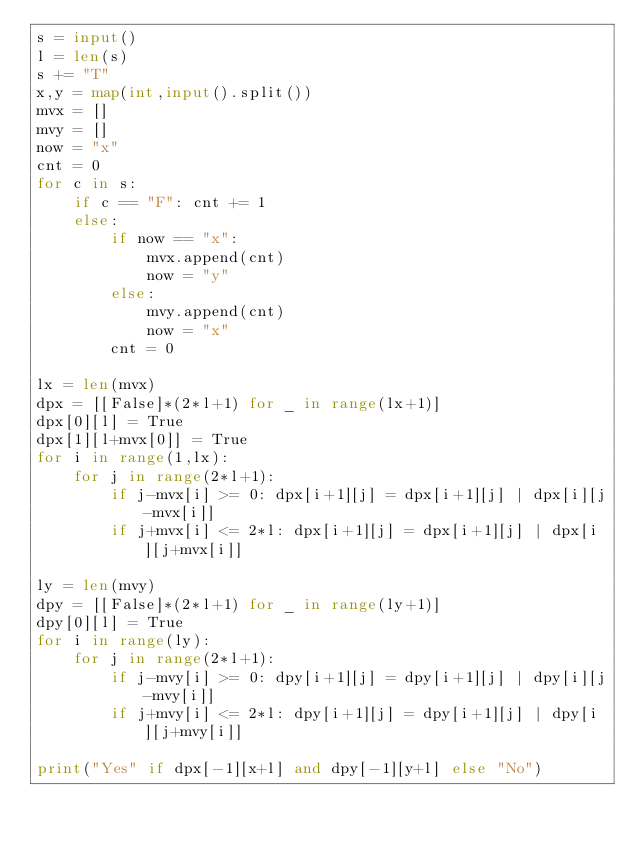Convert code to text. <code><loc_0><loc_0><loc_500><loc_500><_Python_>s = input()
l = len(s)
s += "T"
x,y = map(int,input().split())
mvx = []
mvy = []
now = "x"
cnt = 0
for c in s:
    if c == "F": cnt += 1
    else:
        if now == "x":
            mvx.append(cnt)
            now = "y"
        else:
            mvy.append(cnt)
            now = "x"
        cnt = 0

lx = len(mvx)
dpx = [[False]*(2*l+1) for _ in range(lx+1)]
dpx[0][l] = True
dpx[1][l+mvx[0]] = True
for i in range(1,lx):
    for j in range(2*l+1):
        if j-mvx[i] >= 0: dpx[i+1][j] = dpx[i+1][j] | dpx[i][j-mvx[i]]
        if j+mvx[i] <= 2*l: dpx[i+1][j] = dpx[i+1][j] | dpx[i][j+mvx[i]]

ly = len(mvy)
dpy = [[False]*(2*l+1) for _ in range(ly+1)]
dpy[0][l] = True
for i in range(ly):
    for j in range(2*l+1):
        if j-mvy[i] >= 0: dpy[i+1][j] = dpy[i+1][j] | dpy[i][j-mvy[i]]
        if j+mvy[i] <= 2*l: dpy[i+1][j] = dpy[i+1][j] | dpy[i][j+mvy[i]]

print("Yes" if dpx[-1][x+l] and dpy[-1][y+l] else "No")</code> 